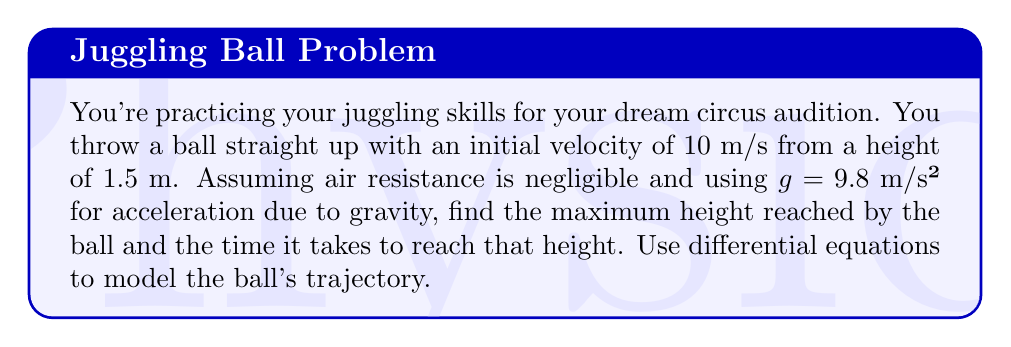Provide a solution to this math problem. Let's approach this step-by-step:

1) First, we need to set up our differential equation. Let $y(t)$ be the height of the ball at time $t$. The acceleration of the ball is constant and equal to $-g$ (negative because it's downward). So we have:

   $$\frac{d^2y}{dt^2} = -g$$

2) We can integrate this once to get velocity:

   $$\frac{dy}{dt} = -gt + C_1$$

   Where $C_1$ is a constant of integration.

3) We know the initial velocity is 10 m/s upward, so at $t=0$, $\frac{dy}{dt} = 10$. This gives us:

   $$10 = -g(0) + C_1$$
   $$C_1 = 10$$

4) So our velocity equation is:

   $$\frac{dy}{dt} = -gt + 10$$

5) Integrating again to get position:

   $$y = -\frac{1}{2}gt^2 + 10t + C_2$$

6) We know the initial height is 1.5 m, so at $t=0$, $y = 1.5$. This gives us:

   $$1.5 = -\frac{1}{2}g(0)^2 + 10(0) + C_2$$
   $$C_2 = 1.5$$

7) So our position equation is:

   $$y = -\frac{1}{2}gt^2 + 10t + 1.5$$

8) To find the maximum height, we need to find when velocity is zero:

   $$0 = -gt + 10$$
   $$t = \frac{10}{g} = \frac{10}{9.8} \approx 1.02\text{ seconds}$$

9) Plugging this time back into our position equation:

   $$y_{max} = -\frac{1}{2}g(\frac{10}{g})^2 + 10(\frac{10}{g}) + 1.5$$
   $$= -\frac{50}{g} + \frac{100}{g} + 1.5$$
   $$= \frac{50}{g} + 1.5$$
   $$= \frac{50}{9.8} + 1.5 \approx 6.60\text{ meters}$$

Therefore, the ball reaches a maximum height of approximately 6.60 meters after about 1.02 seconds.
Answer: Maximum height: 6.60 m, Time to reach maximum height: 1.02 s 